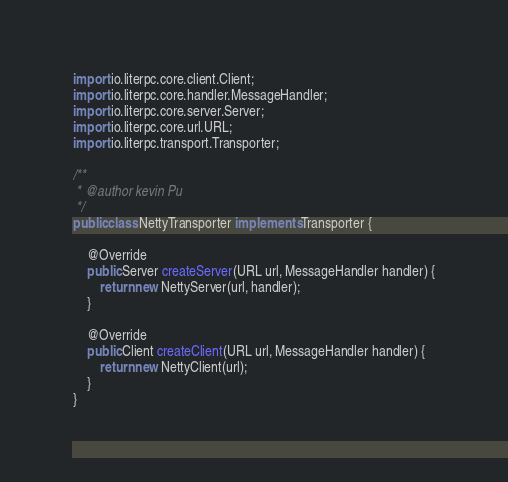<code> <loc_0><loc_0><loc_500><loc_500><_Java_>
import io.literpc.core.client.Client;
import io.literpc.core.handler.MessageHandler;
import io.literpc.core.server.Server;
import io.literpc.core.url.URL;
import io.literpc.transport.Transporter;

/**
 * @author kevin Pu
 */
public class NettyTransporter implements Transporter {

    @Override
    public Server createServer(URL url, MessageHandler handler) {
        return new NettyServer(url, handler);
    }

    @Override
    public Client createClient(URL url, MessageHandler handler) {
        return new NettyClient(url);
    }
}
</code> 